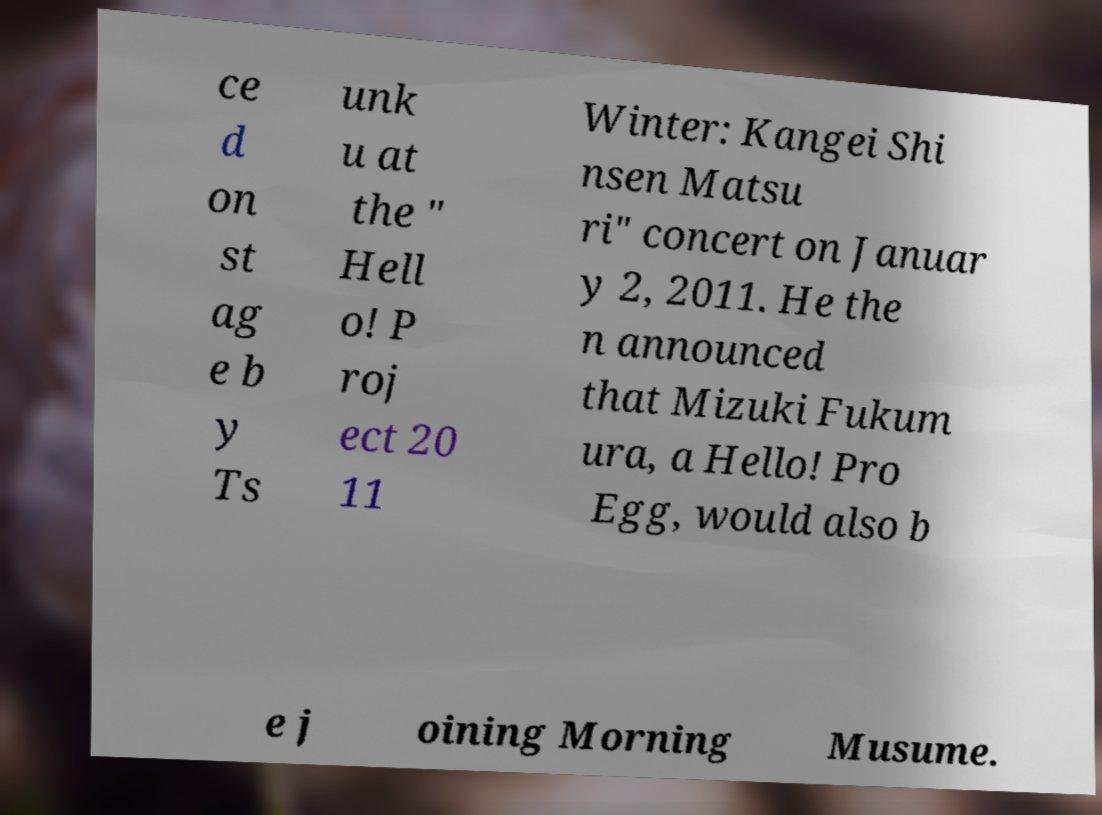There's text embedded in this image that I need extracted. Can you transcribe it verbatim? ce d on st ag e b y Ts unk u at the " Hell o! P roj ect 20 11 Winter: Kangei Shi nsen Matsu ri" concert on Januar y 2, 2011. He the n announced that Mizuki Fukum ura, a Hello! Pro Egg, would also b e j oining Morning Musume. 